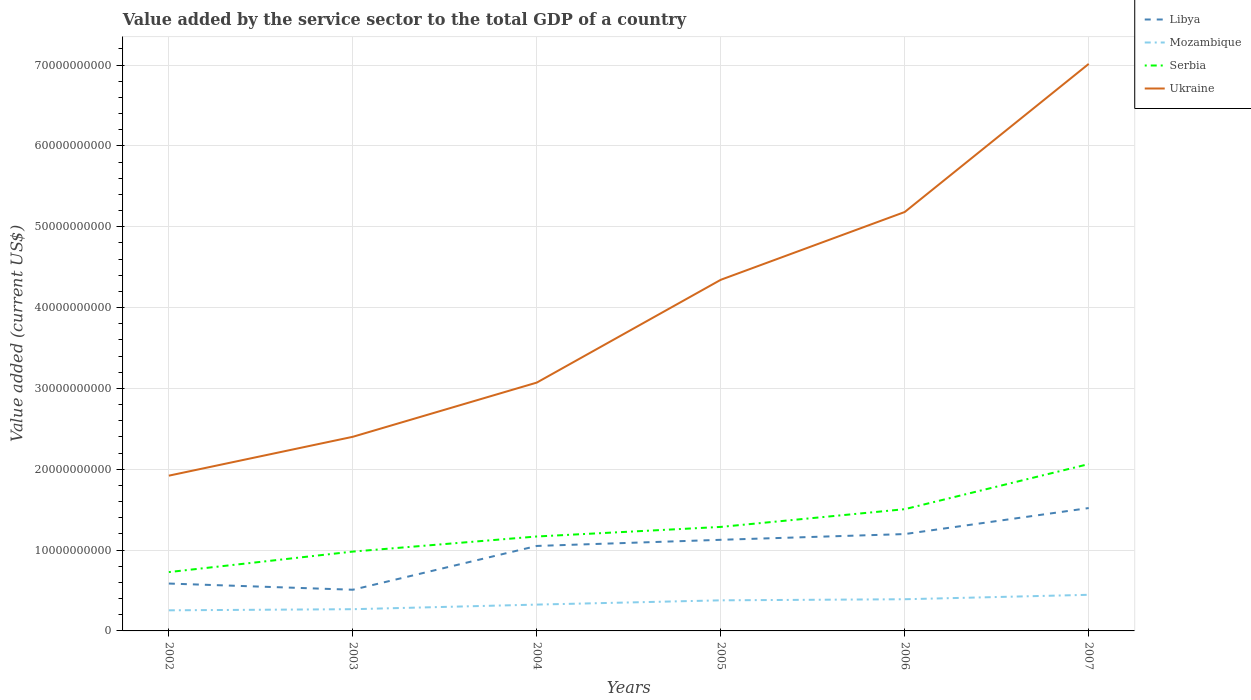Does the line corresponding to Libya intersect with the line corresponding to Ukraine?
Your answer should be compact. No. Is the number of lines equal to the number of legend labels?
Give a very brief answer. Yes. Across all years, what is the maximum value added by the service sector to the total GDP in Mozambique?
Ensure brevity in your answer.  2.55e+09. What is the total value added by the service sector to the total GDP in Serbia in the graph?
Ensure brevity in your answer.  -2.54e+09. What is the difference between the highest and the second highest value added by the service sector to the total GDP in Libya?
Offer a terse response. 1.01e+1. What is the difference between the highest and the lowest value added by the service sector to the total GDP in Libya?
Make the answer very short. 4. How many lines are there?
Keep it short and to the point. 4. Where does the legend appear in the graph?
Your response must be concise. Top right. How many legend labels are there?
Provide a succinct answer. 4. How are the legend labels stacked?
Offer a very short reply. Vertical. What is the title of the graph?
Provide a succinct answer. Value added by the service sector to the total GDP of a country. What is the label or title of the Y-axis?
Provide a short and direct response. Value added (current US$). What is the Value added (current US$) in Libya in 2002?
Give a very brief answer. 5.86e+09. What is the Value added (current US$) in Mozambique in 2002?
Provide a short and direct response. 2.55e+09. What is the Value added (current US$) of Serbia in 2002?
Ensure brevity in your answer.  7.28e+09. What is the Value added (current US$) of Ukraine in 2002?
Ensure brevity in your answer.  1.92e+1. What is the Value added (current US$) in Libya in 2003?
Your response must be concise. 5.09e+09. What is the Value added (current US$) of Mozambique in 2003?
Ensure brevity in your answer.  2.69e+09. What is the Value added (current US$) of Serbia in 2003?
Keep it short and to the point. 9.81e+09. What is the Value added (current US$) in Ukraine in 2003?
Your answer should be compact. 2.40e+1. What is the Value added (current US$) in Libya in 2004?
Keep it short and to the point. 1.05e+1. What is the Value added (current US$) in Mozambique in 2004?
Your answer should be compact. 3.26e+09. What is the Value added (current US$) of Serbia in 2004?
Offer a terse response. 1.17e+1. What is the Value added (current US$) in Ukraine in 2004?
Your response must be concise. 3.07e+1. What is the Value added (current US$) of Libya in 2005?
Provide a short and direct response. 1.13e+1. What is the Value added (current US$) of Mozambique in 2005?
Your answer should be very brief. 3.78e+09. What is the Value added (current US$) of Serbia in 2005?
Your answer should be very brief. 1.29e+1. What is the Value added (current US$) of Ukraine in 2005?
Make the answer very short. 4.34e+1. What is the Value added (current US$) of Libya in 2006?
Your answer should be compact. 1.20e+1. What is the Value added (current US$) of Mozambique in 2006?
Provide a short and direct response. 3.92e+09. What is the Value added (current US$) in Serbia in 2006?
Provide a short and direct response. 1.51e+1. What is the Value added (current US$) in Ukraine in 2006?
Provide a short and direct response. 5.18e+1. What is the Value added (current US$) of Libya in 2007?
Provide a short and direct response. 1.52e+1. What is the Value added (current US$) of Mozambique in 2007?
Provide a short and direct response. 4.47e+09. What is the Value added (current US$) of Serbia in 2007?
Provide a succinct answer. 2.06e+1. What is the Value added (current US$) in Ukraine in 2007?
Provide a succinct answer. 7.01e+1. Across all years, what is the maximum Value added (current US$) of Libya?
Your response must be concise. 1.52e+1. Across all years, what is the maximum Value added (current US$) in Mozambique?
Give a very brief answer. 4.47e+09. Across all years, what is the maximum Value added (current US$) in Serbia?
Provide a short and direct response. 2.06e+1. Across all years, what is the maximum Value added (current US$) in Ukraine?
Your response must be concise. 7.01e+1. Across all years, what is the minimum Value added (current US$) of Libya?
Your answer should be compact. 5.09e+09. Across all years, what is the minimum Value added (current US$) in Mozambique?
Keep it short and to the point. 2.55e+09. Across all years, what is the minimum Value added (current US$) of Serbia?
Offer a very short reply. 7.28e+09. Across all years, what is the minimum Value added (current US$) in Ukraine?
Offer a terse response. 1.92e+1. What is the total Value added (current US$) of Libya in the graph?
Make the answer very short. 5.99e+1. What is the total Value added (current US$) in Mozambique in the graph?
Provide a succinct answer. 2.07e+1. What is the total Value added (current US$) of Serbia in the graph?
Give a very brief answer. 7.73e+1. What is the total Value added (current US$) of Ukraine in the graph?
Keep it short and to the point. 2.39e+11. What is the difference between the Value added (current US$) of Libya in 2002 and that in 2003?
Offer a terse response. 7.65e+08. What is the difference between the Value added (current US$) in Mozambique in 2002 and that in 2003?
Ensure brevity in your answer.  -1.39e+08. What is the difference between the Value added (current US$) of Serbia in 2002 and that in 2003?
Offer a terse response. -2.54e+09. What is the difference between the Value added (current US$) of Ukraine in 2002 and that in 2003?
Ensure brevity in your answer.  -4.81e+09. What is the difference between the Value added (current US$) of Libya in 2002 and that in 2004?
Make the answer very short. -4.65e+09. What is the difference between the Value added (current US$) in Mozambique in 2002 and that in 2004?
Provide a short and direct response. -7.08e+08. What is the difference between the Value added (current US$) in Serbia in 2002 and that in 2004?
Provide a succinct answer. -4.40e+09. What is the difference between the Value added (current US$) in Ukraine in 2002 and that in 2004?
Offer a terse response. -1.15e+1. What is the difference between the Value added (current US$) in Libya in 2002 and that in 2005?
Offer a very short reply. -5.41e+09. What is the difference between the Value added (current US$) of Mozambique in 2002 and that in 2005?
Offer a very short reply. -1.24e+09. What is the difference between the Value added (current US$) of Serbia in 2002 and that in 2005?
Your answer should be compact. -5.59e+09. What is the difference between the Value added (current US$) of Ukraine in 2002 and that in 2005?
Offer a very short reply. -2.42e+1. What is the difference between the Value added (current US$) in Libya in 2002 and that in 2006?
Ensure brevity in your answer.  -6.12e+09. What is the difference between the Value added (current US$) of Mozambique in 2002 and that in 2006?
Give a very brief answer. -1.37e+09. What is the difference between the Value added (current US$) of Serbia in 2002 and that in 2006?
Offer a terse response. -7.78e+09. What is the difference between the Value added (current US$) of Ukraine in 2002 and that in 2006?
Keep it short and to the point. -3.26e+1. What is the difference between the Value added (current US$) of Libya in 2002 and that in 2007?
Offer a very short reply. -9.34e+09. What is the difference between the Value added (current US$) of Mozambique in 2002 and that in 2007?
Offer a very short reply. -1.92e+09. What is the difference between the Value added (current US$) of Serbia in 2002 and that in 2007?
Keep it short and to the point. -1.34e+1. What is the difference between the Value added (current US$) in Ukraine in 2002 and that in 2007?
Provide a succinct answer. -5.09e+1. What is the difference between the Value added (current US$) of Libya in 2003 and that in 2004?
Keep it short and to the point. -5.42e+09. What is the difference between the Value added (current US$) of Mozambique in 2003 and that in 2004?
Your answer should be compact. -5.69e+08. What is the difference between the Value added (current US$) of Serbia in 2003 and that in 2004?
Keep it short and to the point. -1.87e+09. What is the difference between the Value added (current US$) of Ukraine in 2003 and that in 2004?
Keep it short and to the point. -6.70e+09. What is the difference between the Value added (current US$) of Libya in 2003 and that in 2005?
Provide a succinct answer. -6.18e+09. What is the difference between the Value added (current US$) in Mozambique in 2003 and that in 2005?
Provide a succinct answer. -1.10e+09. What is the difference between the Value added (current US$) in Serbia in 2003 and that in 2005?
Provide a short and direct response. -3.05e+09. What is the difference between the Value added (current US$) of Ukraine in 2003 and that in 2005?
Make the answer very short. -1.94e+1. What is the difference between the Value added (current US$) in Libya in 2003 and that in 2006?
Offer a terse response. -6.89e+09. What is the difference between the Value added (current US$) in Mozambique in 2003 and that in 2006?
Your answer should be very brief. -1.23e+09. What is the difference between the Value added (current US$) of Serbia in 2003 and that in 2006?
Your answer should be very brief. -5.25e+09. What is the difference between the Value added (current US$) of Ukraine in 2003 and that in 2006?
Offer a very short reply. -2.78e+1. What is the difference between the Value added (current US$) in Libya in 2003 and that in 2007?
Provide a short and direct response. -1.01e+1. What is the difference between the Value added (current US$) in Mozambique in 2003 and that in 2007?
Your answer should be compact. -1.78e+09. What is the difference between the Value added (current US$) in Serbia in 2003 and that in 2007?
Provide a short and direct response. -1.08e+1. What is the difference between the Value added (current US$) of Ukraine in 2003 and that in 2007?
Provide a short and direct response. -4.61e+1. What is the difference between the Value added (current US$) in Libya in 2004 and that in 2005?
Offer a very short reply. -7.60e+08. What is the difference between the Value added (current US$) of Mozambique in 2004 and that in 2005?
Make the answer very short. -5.28e+08. What is the difference between the Value added (current US$) of Serbia in 2004 and that in 2005?
Keep it short and to the point. -1.18e+09. What is the difference between the Value added (current US$) of Ukraine in 2004 and that in 2005?
Provide a short and direct response. -1.27e+1. What is the difference between the Value added (current US$) of Libya in 2004 and that in 2006?
Keep it short and to the point. -1.47e+09. What is the difference between the Value added (current US$) in Mozambique in 2004 and that in 2006?
Offer a very short reply. -6.63e+08. What is the difference between the Value added (current US$) in Serbia in 2004 and that in 2006?
Ensure brevity in your answer.  -3.38e+09. What is the difference between the Value added (current US$) in Ukraine in 2004 and that in 2006?
Your answer should be very brief. -2.11e+1. What is the difference between the Value added (current US$) of Libya in 2004 and that in 2007?
Keep it short and to the point. -4.69e+09. What is the difference between the Value added (current US$) of Mozambique in 2004 and that in 2007?
Offer a terse response. -1.21e+09. What is the difference between the Value added (current US$) in Serbia in 2004 and that in 2007?
Offer a terse response. -8.96e+09. What is the difference between the Value added (current US$) of Ukraine in 2004 and that in 2007?
Offer a very short reply. -3.94e+1. What is the difference between the Value added (current US$) in Libya in 2005 and that in 2006?
Offer a terse response. -7.10e+08. What is the difference between the Value added (current US$) of Mozambique in 2005 and that in 2006?
Offer a terse response. -1.35e+08. What is the difference between the Value added (current US$) of Serbia in 2005 and that in 2006?
Your response must be concise. -2.19e+09. What is the difference between the Value added (current US$) of Ukraine in 2005 and that in 2006?
Give a very brief answer. -8.39e+09. What is the difference between the Value added (current US$) in Libya in 2005 and that in 2007?
Your response must be concise. -3.93e+09. What is the difference between the Value added (current US$) in Mozambique in 2005 and that in 2007?
Provide a succinct answer. -6.84e+08. What is the difference between the Value added (current US$) in Serbia in 2005 and that in 2007?
Keep it short and to the point. -7.77e+09. What is the difference between the Value added (current US$) in Ukraine in 2005 and that in 2007?
Your answer should be very brief. -2.67e+1. What is the difference between the Value added (current US$) of Libya in 2006 and that in 2007?
Offer a very short reply. -3.22e+09. What is the difference between the Value added (current US$) of Mozambique in 2006 and that in 2007?
Ensure brevity in your answer.  -5.49e+08. What is the difference between the Value added (current US$) in Serbia in 2006 and that in 2007?
Provide a succinct answer. -5.58e+09. What is the difference between the Value added (current US$) of Ukraine in 2006 and that in 2007?
Your answer should be compact. -1.83e+1. What is the difference between the Value added (current US$) of Libya in 2002 and the Value added (current US$) of Mozambique in 2003?
Your response must be concise. 3.17e+09. What is the difference between the Value added (current US$) in Libya in 2002 and the Value added (current US$) in Serbia in 2003?
Make the answer very short. -3.95e+09. What is the difference between the Value added (current US$) of Libya in 2002 and the Value added (current US$) of Ukraine in 2003?
Offer a very short reply. -1.82e+1. What is the difference between the Value added (current US$) in Mozambique in 2002 and the Value added (current US$) in Serbia in 2003?
Provide a succinct answer. -7.27e+09. What is the difference between the Value added (current US$) in Mozambique in 2002 and the Value added (current US$) in Ukraine in 2003?
Your response must be concise. -2.15e+1. What is the difference between the Value added (current US$) in Serbia in 2002 and the Value added (current US$) in Ukraine in 2003?
Give a very brief answer. -1.67e+1. What is the difference between the Value added (current US$) of Libya in 2002 and the Value added (current US$) of Mozambique in 2004?
Your answer should be compact. 2.60e+09. What is the difference between the Value added (current US$) of Libya in 2002 and the Value added (current US$) of Serbia in 2004?
Offer a terse response. -5.82e+09. What is the difference between the Value added (current US$) in Libya in 2002 and the Value added (current US$) in Ukraine in 2004?
Provide a short and direct response. -2.49e+1. What is the difference between the Value added (current US$) in Mozambique in 2002 and the Value added (current US$) in Serbia in 2004?
Your response must be concise. -9.13e+09. What is the difference between the Value added (current US$) of Mozambique in 2002 and the Value added (current US$) of Ukraine in 2004?
Offer a very short reply. -2.82e+1. What is the difference between the Value added (current US$) of Serbia in 2002 and the Value added (current US$) of Ukraine in 2004?
Ensure brevity in your answer.  -2.34e+1. What is the difference between the Value added (current US$) of Libya in 2002 and the Value added (current US$) of Mozambique in 2005?
Ensure brevity in your answer.  2.07e+09. What is the difference between the Value added (current US$) in Libya in 2002 and the Value added (current US$) in Serbia in 2005?
Keep it short and to the point. -7.01e+09. What is the difference between the Value added (current US$) in Libya in 2002 and the Value added (current US$) in Ukraine in 2005?
Provide a short and direct response. -3.76e+1. What is the difference between the Value added (current US$) of Mozambique in 2002 and the Value added (current US$) of Serbia in 2005?
Your answer should be compact. -1.03e+1. What is the difference between the Value added (current US$) in Mozambique in 2002 and the Value added (current US$) in Ukraine in 2005?
Your answer should be very brief. -4.09e+1. What is the difference between the Value added (current US$) in Serbia in 2002 and the Value added (current US$) in Ukraine in 2005?
Provide a succinct answer. -3.62e+1. What is the difference between the Value added (current US$) in Libya in 2002 and the Value added (current US$) in Mozambique in 2006?
Provide a short and direct response. 1.94e+09. What is the difference between the Value added (current US$) in Libya in 2002 and the Value added (current US$) in Serbia in 2006?
Your answer should be compact. -9.20e+09. What is the difference between the Value added (current US$) in Libya in 2002 and the Value added (current US$) in Ukraine in 2006?
Make the answer very short. -4.60e+1. What is the difference between the Value added (current US$) of Mozambique in 2002 and the Value added (current US$) of Serbia in 2006?
Your response must be concise. -1.25e+1. What is the difference between the Value added (current US$) of Mozambique in 2002 and the Value added (current US$) of Ukraine in 2006?
Provide a succinct answer. -4.93e+1. What is the difference between the Value added (current US$) of Serbia in 2002 and the Value added (current US$) of Ukraine in 2006?
Provide a succinct answer. -4.45e+1. What is the difference between the Value added (current US$) of Libya in 2002 and the Value added (current US$) of Mozambique in 2007?
Provide a short and direct response. 1.39e+09. What is the difference between the Value added (current US$) in Libya in 2002 and the Value added (current US$) in Serbia in 2007?
Provide a short and direct response. -1.48e+1. What is the difference between the Value added (current US$) of Libya in 2002 and the Value added (current US$) of Ukraine in 2007?
Provide a succinct answer. -6.43e+1. What is the difference between the Value added (current US$) of Mozambique in 2002 and the Value added (current US$) of Serbia in 2007?
Offer a terse response. -1.81e+1. What is the difference between the Value added (current US$) in Mozambique in 2002 and the Value added (current US$) in Ukraine in 2007?
Provide a succinct answer. -6.76e+1. What is the difference between the Value added (current US$) of Serbia in 2002 and the Value added (current US$) of Ukraine in 2007?
Keep it short and to the point. -6.29e+1. What is the difference between the Value added (current US$) in Libya in 2003 and the Value added (current US$) in Mozambique in 2004?
Keep it short and to the point. 1.84e+09. What is the difference between the Value added (current US$) in Libya in 2003 and the Value added (current US$) in Serbia in 2004?
Your response must be concise. -6.59e+09. What is the difference between the Value added (current US$) of Libya in 2003 and the Value added (current US$) of Ukraine in 2004?
Provide a succinct answer. -2.56e+1. What is the difference between the Value added (current US$) in Mozambique in 2003 and the Value added (current US$) in Serbia in 2004?
Your answer should be very brief. -8.99e+09. What is the difference between the Value added (current US$) of Mozambique in 2003 and the Value added (current US$) of Ukraine in 2004?
Ensure brevity in your answer.  -2.80e+1. What is the difference between the Value added (current US$) in Serbia in 2003 and the Value added (current US$) in Ukraine in 2004?
Ensure brevity in your answer.  -2.09e+1. What is the difference between the Value added (current US$) of Libya in 2003 and the Value added (current US$) of Mozambique in 2005?
Ensure brevity in your answer.  1.31e+09. What is the difference between the Value added (current US$) of Libya in 2003 and the Value added (current US$) of Serbia in 2005?
Ensure brevity in your answer.  -7.77e+09. What is the difference between the Value added (current US$) of Libya in 2003 and the Value added (current US$) of Ukraine in 2005?
Ensure brevity in your answer.  -3.83e+1. What is the difference between the Value added (current US$) in Mozambique in 2003 and the Value added (current US$) in Serbia in 2005?
Give a very brief answer. -1.02e+1. What is the difference between the Value added (current US$) in Mozambique in 2003 and the Value added (current US$) in Ukraine in 2005?
Keep it short and to the point. -4.07e+1. What is the difference between the Value added (current US$) in Serbia in 2003 and the Value added (current US$) in Ukraine in 2005?
Give a very brief answer. -3.36e+1. What is the difference between the Value added (current US$) of Libya in 2003 and the Value added (current US$) of Mozambique in 2006?
Your answer should be compact. 1.18e+09. What is the difference between the Value added (current US$) of Libya in 2003 and the Value added (current US$) of Serbia in 2006?
Give a very brief answer. -9.97e+09. What is the difference between the Value added (current US$) in Libya in 2003 and the Value added (current US$) in Ukraine in 2006?
Provide a succinct answer. -4.67e+1. What is the difference between the Value added (current US$) of Mozambique in 2003 and the Value added (current US$) of Serbia in 2006?
Provide a succinct answer. -1.24e+1. What is the difference between the Value added (current US$) in Mozambique in 2003 and the Value added (current US$) in Ukraine in 2006?
Give a very brief answer. -4.91e+1. What is the difference between the Value added (current US$) in Serbia in 2003 and the Value added (current US$) in Ukraine in 2006?
Offer a terse response. -4.20e+1. What is the difference between the Value added (current US$) in Libya in 2003 and the Value added (current US$) in Mozambique in 2007?
Your answer should be very brief. 6.26e+08. What is the difference between the Value added (current US$) of Libya in 2003 and the Value added (current US$) of Serbia in 2007?
Make the answer very short. -1.55e+1. What is the difference between the Value added (current US$) of Libya in 2003 and the Value added (current US$) of Ukraine in 2007?
Provide a succinct answer. -6.50e+1. What is the difference between the Value added (current US$) of Mozambique in 2003 and the Value added (current US$) of Serbia in 2007?
Keep it short and to the point. -1.80e+1. What is the difference between the Value added (current US$) of Mozambique in 2003 and the Value added (current US$) of Ukraine in 2007?
Your response must be concise. -6.75e+1. What is the difference between the Value added (current US$) in Serbia in 2003 and the Value added (current US$) in Ukraine in 2007?
Keep it short and to the point. -6.03e+1. What is the difference between the Value added (current US$) in Libya in 2004 and the Value added (current US$) in Mozambique in 2005?
Provide a short and direct response. 6.73e+09. What is the difference between the Value added (current US$) of Libya in 2004 and the Value added (current US$) of Serbia in 2005?
Ensure brevity in your answer.  -2.36e+09. What is the difference between the Value added (current US$) in Libya in 2004 and the Value added (current US$) in Ukraine in 2005?
Provide a succinct answer. -3.29e+1. What is the difference between the Value added (current US$) in Mozambique in 2004 and the Value added (current US$) in Serbia in 2005?
Ensure brevity in your answer.  -9.61e+09. What is the difference between the Value added (current US$) of Mozambique in 2004 and the Value added (current US$) of Ukraine in 2005?
Give a very brief answer. -4.02e+1. What is the difference between the Value added (current US$) in Serbia in 2004 and the Value added (current US$) in Ukraine in 2005?
Make the answer very short. -3.18e+1. What is the difference between the Value added (current US$) of Libya in 2004 and the Value added (current US$) of Mozambique in 2006?
Ensure brevity in your answer.  6.59e+09. What is the difference between the Value added (current US$) in Libya in 2004 and the Value added (current US$) in Serbia in 2006?
Your response must be concise. -4.55e+09. What is the difference between the Value added (current US$) in Libya in 2004 and the Value added (current US$) in Ukraine in 2006?
Offer a terse response. -4.13e+1. What is the difference between the Value added (current US$) in Mozambique in 2004 and the Value added (current US$) in Serbia in 2006?
Your answer should be very brief. -1.18e+1. What is the difference between the Value added (current US$) of Mozambique in 2004 and the Value added (current US$) of Ukraine in 2006?
Your answer should be compact. -4.86e+1. What is the difference between the Value added (current US$) in Serbia in 2004 and the Value added (current US$) in Ukraine in 2006?
Keep it short and to the point. -4.01e+1. What is the difference between the Value added (current US$) in Libya in 2004 and the Value added (current US$) in Mozambique in 2007?
Ensure brevity in your answer.  6.04e+09. What is the difference between the Value added (current US$) of Libya in 2004 and the Value added (current US$) of Serbia in 2007?
Your answer should be very brief. -1.01e+1. What is the difference between the Value added (current US$) in Libya in 2004 and the Value added (current US$) in Ukraine in 2007?
Make the answer very short. -5.96e+1. What is the difference between the Value added (current US$) in Mozambique in 2004 and the Value added (current US$) in Serbia in 2007?
Give a very brief answer. -1.74e+1. What is the difference between the Value added (current US$) of Mozambique in 2004 and the Value added (current US$) of Ukraine in 2007?
Ensure brevity in your answer.  -6.69e+1. What is the difference between the Value added (current US$) in Serbia in 2004 and the Value added (current US$) in Ukraine in 2007?
Offer a very short reply. -5.85e+1. What is the difference between the Value added (current US$) of Libya in 2005 and the Value added (current US$) of Mozambique in 2006?
Provide a succinct answer. 7.35e+09. What is the difference between the Value added (current US$) of Libya in 2005 and the Value added (current US$) of Serbia in 2006?
Your answer should be very brief. -3.79e+09. What is the difference between the Value added (current US$) in Libya in 2005 and the Value added (current US$) in Ukraine in 2006?
Your answer should be compact. -4.06e+1. What is the difference between the Value added (current US$) of Mozambique in 2005 and the Value added (current US$) of Serbia in 2006?
Ensure brevity in your answer.  -1.13e+1. What is the difference between the Value added (current US$) in Mozambique in 2005 and the Value added (current US$) in Ukraine in 2006?
Provide a short and direct response. -4.80e+1. What is the difference between the Value added (current US$) in Serbia in 2005 and the Value added (current US$) in Ukraine in 2006?
Your answer should be compact. -3.90e+1. What is the difference between the Value added (current US$) in Libya in 2005 and the Value added (current US$) in Mozambique in 2007?
Make the answer very short. 6.80e+09. What is the difference between the Value added (current US$) in Libya in 2005 and the Value added (current US$) in Serbia in 2007?
Provide a short and direct response. -9.37e+09. What is the difference between the Value added (current US$) of Libya in 2005 and the Value added (current US$) of Ukraine in 2007?
Provide a succinct answer. -5.89e+1. What is the difference between the Value added (current US$) of Mozambique in 2005 and the Value added (current US$) of Serbia in 2007?
Provide a succinct answer. -1.69e+1. What is the difference between the Value added (current US$) of Mozambique in 2005 and the Value added (current US$) of Ukraine in 2007?
Make the answer very short. -6.64e+1. What is the difference between the Value added (current US$) of Serbia in 2005 and the Value added (current US$) of Ukraine in 2007?
Your answer should be compact. -5.73e+1. What is the difference between the Value added (current US$) of Libya in 2006 and the Value added (current US$) of Mozambique in 2007?
Your answer should be compact. 7.51e+09. What is the difference between the Value added (current US$) of Libya in 2006 and the Value added (current US$) of Serbia in 2007?
Give a very brief answer. -8.66e+09. What is the difference between the Value added (current US$) of Libya in 2006 and the Value added (current US$) of Ukraine in 2007?
Provide a short and direct response. -5.82e+1. What is the difference between the Value added (current US$) in Mozambique in 2006 and the Value added (current US$) in Serbia in 2007?
Your answer should be compact. -1.67e+1. What is the difference between the Value added (current US$) of Mozambique in 2006 and the Value added (current US$) of Ukraine in 2007?
Keep it short and to the point. -6.62e+1. What is the difference between the Value added (current US$) of Serbia in 2006 and the Value added (current US$) of Ukraine in 2007?
Provide a short and direct response. -5.51e+1. What is the average Value added (current US$) of Libya per year?
Offer a terse response. 9.99e+09. What is the average Value added (current US$) of Mozambique per year?
Offer a terse response. 3.44e+09. What is the average Value added (current US$) of Serbia per year?
Make the answer very short. 1.29e+1. What is the average Value added (current US$) of Ukraine per year?
Provide a short and direct response. 3.99e+1. In the year 2002, what is the difference between the Value added (current US$) of Libya and Value added (current US$) of Mozambique?
Ensure brevity in your answer.  3.31e+09. In the year 2002, what is the difference between the Value added (current US$) in Libya and Value added (current US$) in Serbia?
Provide a short and direct response. -1.42e+09. In the year 2002, what is the difference between the Value added (current US$) in Libya and Value added (current US$) in Ukraine?
Ensure brevity in your answer.  -1.33e+1. In the year 2002, what is the difference between the Value added (current US$) in Mozambique and Value added (current US$) in Serbia?
Keep it short and to the point. -4.73e+09. In the year 2002, what is the difference between the Value added (current US$) of Mozambique and Value added (current US$) of Ukraine?
Offer a very short reply. -1.67e+1. In the year 2002, what is the difference between the Value added (current US$) in Serbia and Value added (current US$) in Ukraine?
Provide a short and direct response. -1.19e+1. In the year 2003, what is the difference between the Value added (current US$) in Libya and Value added (current US$) in Mozambique?
Your answer should be compact. 2.41e+09. In the year 2003, what is the difference between the Value added (current US$) of Libya and Value added (current US$) of Serbia?
Provide a short and direct response. -4.72e+09. In the year 2003, what is the difference between the Value added (current US$) of Libya and Value added (current US$) of Ukraine?
Provide a succinct answer. -1.89e+1. In the year 2003, what is the difference between the Value added (current US$) of Mozambique and Value added (current US$) of Serbia?
Your response must be concise. -7.13e+09. In the year 2003, what is the difference between the Value added (current US$) of Mozambique and Value added (current US$) of Ukraine?
Offer a very short reply. -2.13e+1. In the year 2003, what is the difference between the Value added (current US$) of Serbia and Value added (current US$) of Ukraine?
Ensure brevity in your answer.  -1.42e+1. In the year 2004, what is the difference between the Value added (current US$) in Libya and Value added (current US$) in Mozambique?
Give a very brief answer. 7.25e+09. In the year 2004, what is the difference between the Value added (current US$) of Libya and Value added (current US$) of Serbia?
Keep it short and to the point. -1.17e+09. In the year 2004, what is the difference between the Value added (current US$) of Libya and Value added (current US$) of Ukraine?
Offer a terse response. -2.02e+1. In the year 2004, what is the difference between the Value added (current US$) in Mozambique and Value added (current US$) in Serbia?
Offer a terse response. -8.43e+09. In the year 2004, what is the difference between the Value added (current US$) of Mozambique and Value added (current US$) of Ukraine?
Provide a short and direct response. -2.75e+1. In the year 2004, what is the difference between the Value added (current US$) in Serbia and Value added (current US$) in Ukraine?
Your response must be concise. -1.90e+1. In the year 2005, what is the difference between the Value added (current US$) of Libya and Value added (current US$) of Mozambique?
Provide a short and direct response. 7.49e+09. In the year 2005, what is the difference between the Value added (current US$) in Libya and Value added (current US$) in Serbia?
Make the answer very short. -1.60e+09. In the year 2005, what is the difference between the Value added (current US$) of Libya and Value added (current US$) of Ukraine?
Offer a terse response. -3.22e+1. In the year 2005, what is the difference between the Value added (current US$) in Mozambique and Value added (current US$) in Serbia?
Offer a very short reply. -9.08e+09. In the year 2005, what is the difference between the Value added (current US$) of Mozambique and Value added (current US$) of Ukraine?
Your answer should be very brief. -3.97e+1. In the year 2005, what is the difference between the Value added (current US$) of Serbia and Value added (current US$) of Ukraine?
Provide a short and direct response. -3.06e+1. In the year 2006, what is the difference between the Value added (current US$) in Libya and Value added (current US$) in Mozambique?
Provide a succinct answer. 8.06e+09. In the year 2006, what is the difference between the Value added (current US$) of Libya and Value added (current US$) of Serbia?
Your answer should be very brief. -3.08e+09. In the year 2006, what is the difference between the Value added (current US$) of Libya and Value added (current US$) of Ukraine?
Ensure brevity in your answer.  -3.98e+1. In the year 2006, what is the difference between the Value added (current US$) of Mozambique and Value added (current US$) of Serbia?
Your answer should be very brief. -1.11e+1. In the year 2006, what is the difference between the Value added (current US$) in Mozambique and Value added (current US$) in Ukraine?
Provide a short and direct response. -4.79e+1. In the year 2006, what is the difference between the Value added (current US$) of Serbia and Value added (current US$) of Ukraine?
Offer a very short reply. -3.68e+1. In the year 2007, what is the difference between the Value added (current US$) of Libya and Value added (current US$) of Mozambique?
Keep it short and to the point. 1.07e+1. In the year 2007, what is the difference between the Value added (current US$) of Libya and Value added (current US$) of Serbia?
Your response must be concise. -5.44e+09. In the year 2007, what is the difference between the Value added (current US$) in Libya and Value added (current US$) in Ukraine?
Your response must be concise. -5.49e+1. In the year 2007, what is the difference between the Value added (current US$) in Mozambique and Value added (current US$) in Serbia?
Your response must be concise. -1.62e+1. In the year 2007, what is the difference between the Value added (current US$) of Mozambique and Value added (current US$) of Ukraine?
Keep it short and to the point. -6.57e+1. In the year 2007, what is the difference between the Value added (current US$) of Serbia and Value added (current US$) of Ukraine?
Make the answer very short. -4.95e+1. What is the ratio of the Value added (current US$) in Libya in 2002 to that in 2003?
Your answer should be compact. 1.15. What is the ratio of the Value added (current US$) of Mozambique in 2002 to that in 2003?
Make the answer very short. 0.95. What is the ratio of the Value added (current US$) of Serbia in 2002 to that in 2003?
Offer a terse response. 0.74. What is the ratio of the Value added (current US$) of Ukraine in 2002 to that in 2003?
Keep it short and to the point. 0.8. What is the ratio of the Value added (current US$) of Libya in 2002 to that in 2004?
Offer a terse response. 0.56. What is the ratio of the Value added (current US$) of Mozambique in 2002 to that in 2004?
Your answer should be very brief. 0.78. What is the ratio of the Value added (current US$) in Serbia in 2002 to that in 2004?
Give a very brief answer. 0.62. What is the ratio of the Value added (current US$) in Ukraine in 2002 to that in 2004?
Ensure brevity in your answer.  0.63. What is the ratio of the Value added (current US$) of Libya in 2002 to that in 2005?
Keep it short and to the point. 0.52. What is the ratio of the Value added (current US$) of Mozambique in 2002 to that in 2005?
Provide a succinct answer. 0.67. What is the ratio of the Value added (current US$) in Serbia in 2002 to that in 2005?
Provide a short and direct response. 0.57. What is the ratio of the Value added (current US$) in Ukraine in 2002 to that in 2005?
Make the answer very short. 0.44. What is the ratio of the Value added (current US$) of Libya in 2002 to that in 2006?
Give a very brief answer. 0.49. What is the ratio of the Value added (current US$) of Mozambique in 2002 to that in 2006?
Provide a succinct answer. 0.65. What is the ratio of the Value added (current US$) in Serbia in 2002 to that in 2006?
Give a very brief answer. 0.48. What is the ratio of the Value added (current US$) of Ukraine in 2002 to that in 2006?
Your answer should be very brief. 0.37. What is the ratio of the Value added (current US$) in Libya in 2002 to that in 2007?
Provide a succinct answer. 0.39. What is the ratio of the Value added (current US$) of Mozambique in 2002 to that in 2007?
Your answer should be compact. 0.57. What is the ratio of the Value added (current US$) of Serbia in 2002 to that in 2007?
Ensure brevity in your answer.  0.35. What is the ratio of the Value added (current US$) in Ukraine in 2002 to that in 2007?
Provide a short and direct response. 0.27. What is the ratio of the Value added (current US$) in Libya in 2003 to that in 2004?
Provide a succinct answer. 0.48. What is the ratio of the Value added (current US$) of Mozambique in 2003 to that in 2004?
Ensure brevity in your answer.  0.83. What is the ratio of the Value added (current US$) in Serbia in 2003 to that in 2004?
Provide a short and direct response. 0.84. What is the ratio of the Value added (current US$) of Ukraine in 2003 to that in 2004?
Provide a short and direct response. 0.78. What is the ratio of the Value added (current US$) in Libya in 2003 to that in 2005?
Your answer should be very brief. 0.45. What is the ratio of the Value added (current US$) in Mozambique in 2003 to that in 2005?
Ensure brevity in your answer.  0.71. What is the ratio of the Value added (current US$) of Serbia in 2003 to that in 2005?
Provide a short and direct response. 0.76. What is the ratio of the Value added (current US$) in Ukraine in 2003 to that in 2005?
Offer a very short reply. 0.55. What is the ratio of the Value added (current US$) in Libya in 2003 to that in 2006?
Make the answer very short. 0.43. What is the ratio of the Value added (current US$) of Mozambique in 2003 to that in 2006?
Provide a succinct answer. 0.69. What is the ratio of the Value added (current US$) in Serbia in 2003 to that in 2006?
Ensure brevity in your answer.  0.65. What is the ratio of the Value added (current US$) in Ukraine in 2003 to that in 2006?
Your answer should be very brief. 0.46. What is the ratio of the Value added (current US$) in Libya in 2003 to that in 2007?
Provide a short and direct response. 0.34. What is the ratio of the Value added (current US$) in Mozambique in 2003 to that in 2007?
Ensure brevity in your answer.  0.6. What is the ratio of the Value added (current US$) in Serbia in 2003 to that in 2007?
Offer a terse response. 0.48. What is the ratio of the Value added (current US$) in Ukraine in 2003 to that in 2007?
Your answer should be compact. 0.34. What is the ratio of the Value added (current US$) in Libya in 2004 to that in 2005?
Offer a very short reply. 0.93. What is the ratio of the Value added (current US$) of Mozambique in 2004 to that in 2005?
Your answer should be compact. 0.86. What is the ratio of the Value added (current US$) in Serbia in 2004 to that in 2005?
Provide a succinct answer. 0.91. What is the ratio of the Value added (current US$) in Ukraine in 2004 to that in 2005?
Make the answer very short. 0.71. What is the ratio of the Value added (current US$) of Libya in 2004 to that in 2006?
Ensure brevity in your answer.  0.88. What is the ratio of the Value added (current US$) in Mozambique in 2004 to that in 2006?
Give a very brief answer. 0.83. What is the ratio of the Value added (current US$) in Serbia in 2004 to that in 2006?
Ensure brevity in your answer.  0.78. What is the ratio of the Value added (current US$) of Ukraine in 2004 to that in 2006?
Your answer should be compact. 0.59. What is the ratio of the Value added (current US$) in Libya in 2004 to that in 2007?
Offer a very short reply. 0.69. What is the ratio of the Value added (current US$) of Mozambique in 2004 to that in 2007?
Ensure brevity in your answer.  0.73. What is the ratio of the Value added (current US$) of Serbia in 2004 to that in 2007?
Ensure brevity in your answer.  0.57. What is the ratio of the Value added (current US$) of Ukraine in 2004 to that in 2007?
Offer a very short reply. 0.44. What is the ratio of the Value added (current US$) of Libya in 2005 to that in 2006?
Your response must be concise. 0.94. What is the ratio of the Value added (current US$) in Mozambique in 2005 to that in 2006?
Your response must be concise. 0.97. What is the ratio of the Value added (current US$) in Serbia in 2005 to that in 2006?
Offer a terse response. 0.85. What is the ratio of the Value added (current US$) of Ukraine in 2005 to that in 2006?
Provide a short and direct response. 0.84. What is the ratio of the Value added (current US$) of Libya in 2005 to that in 2007?
Provide a succinct answer. 0.74. What is the ratio of the Value added (current US$) in Mozambique in 2005 to that in 2007?
Your response must be concise. 0.85. What is the ratio of the Value added (current US$) in Serbia in 2005 to that in 2007?
Offer a terse response. 0.62. What is the ratio of the Value added (current US$) in Ukraine in 2005 to that in 2007?
Ensure brevity in your answer.  0.62. What is the ratio of the Value added (current US$) of Libya in 2006 to that in 2007?
Offer a terse response. 0.79. What is the ratio of the Value added (current US$) in Mozambique in 2006 to that in 2007?
Give a very brief answer. 0.88. What is the ratio of the Value added (current US$) of Serbia in 2006 to that in 2007?
Make the answer very short. 0.73. What is the ratio of the Value added (current US$) in Ukraine in 2006 to that in 2007?
Your answer should be very brief. 0.74. What is the difference between the highest and the second highest Value added (current US$) of Libya?
Ensure brevity in your answer.  3.22e+09. What is the difference between the highest and the second highest Value added (current US$) in Mozambique?
Offer a terse response. 5.49e+08. What is the difference between the highest and the second highest Value added (current US$) of Serbia?
Provide a succinct answer. 5.58e+09. What is the difference between the highest and the second highest Value added (current US$) in Ukraine?
Give a very brief answer. 1.83e+1. What is the difference between the highest and the lowest Value added (current US$) in Libya?
Your answer should be very brief. 1.01e+1. What is the difference between the highest and the lowest Value added (current US$) of Mozambique?
Give a very brief answer. 1.92e+09. What is the difference between the highest and the lowest Value added (current US$) of Serbia?
Offer a terse response. 1.34e+1. What is the difference between the highest and the lowest Value added (current US$) of Ukraine?
Provide a short and direct response. 5.09e+1. 